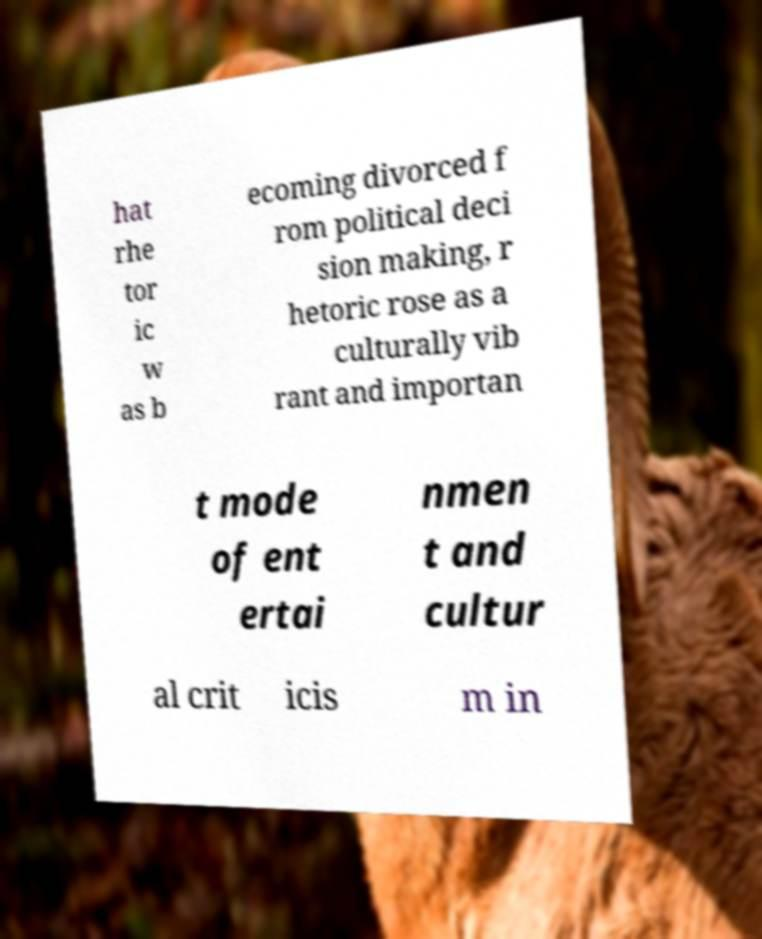Please identify and transcribe the text found in this image. hat rhe tor ic w as b ecoming divorced f rom political deci sion making, r hetoric rose as a culturally vib rant and importan t mode of ent ertai nmen t and cultur al crit icis m in 